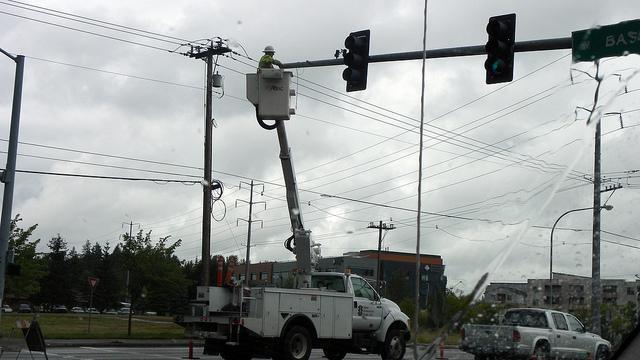What sort of repairs in the lifted person doing?
Answer the question by selecting the correct answer among the 4 following choices.
Options: Animal remediation, pothole, electrical, road sign. Electrical. 